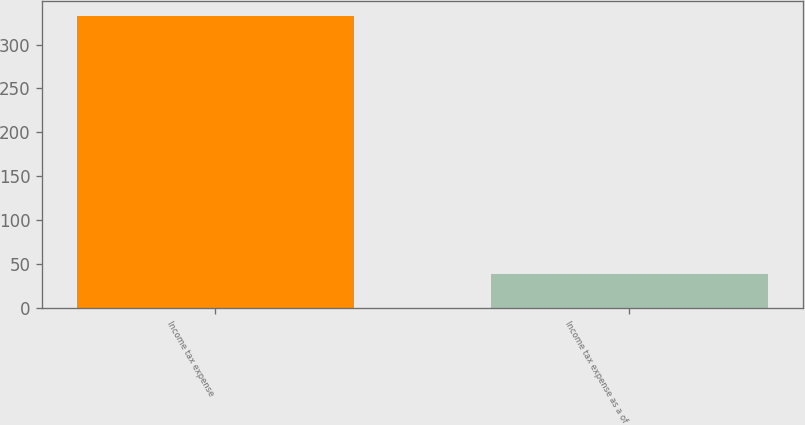Convert chart to OTSL. <chart><loc_0><loc_0><loc_500><loc_500><bar_chart><fcel>Income tax expense<fcel>Income tax expense as a of<nl><fcel>333<fcel>38.4<nl></chart> 